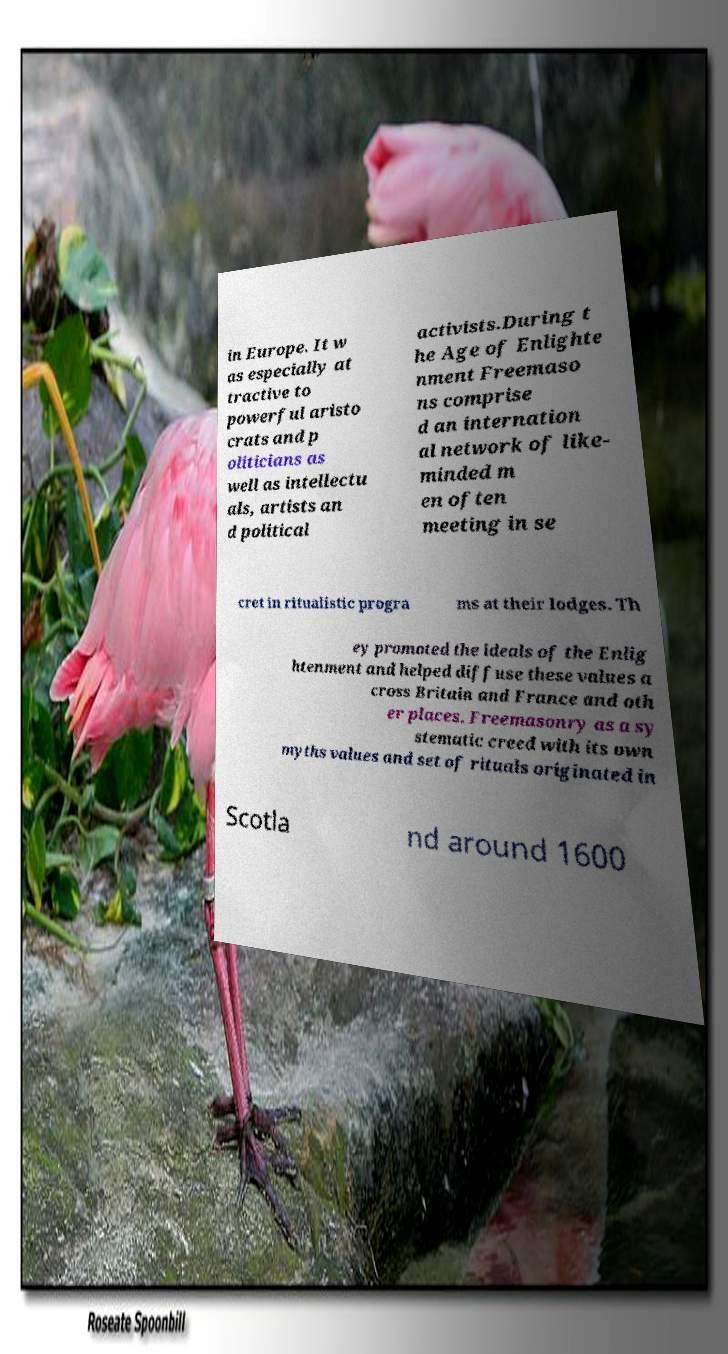I need the written content from this picture converted into text. Can you do that? in Europe. It w as especially at tractive to powerful aristo crats and p oliticians as well as intellectu als, artists an d political activists.During t he Age of Enlighte nment Freemaso ns comprise d an internation al network of like- minded m en often meeting in se cret in ritualistic progra ms at their lodges. Th ey promoted the ideals of the Enlig htenment and helped diffuse these values a cross Britain and France and oth er places. Freemasonry as a sy stematic creed with its own myths values and set of rituals originated in Scotla nd around 1600 